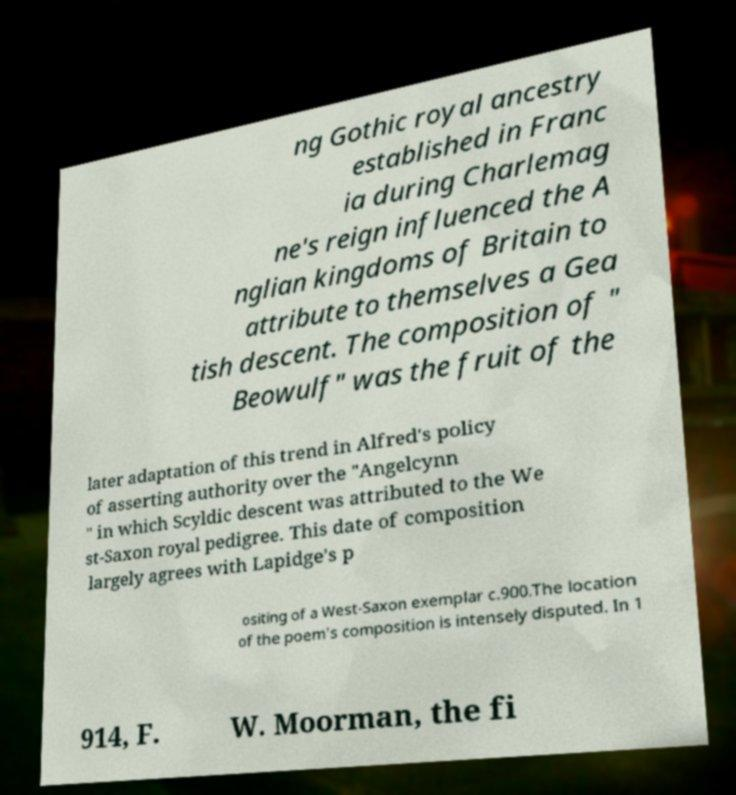Could you assist in decoding the text presented in this image and type it out clearly? ng Gothic royal ancestry established in Franc ia during Charlemag ne's reign influenced the A nglian kingdoms of Britain to attribute to themselves a Gea tish descent. The composition of " Beowulf" was the fruit of the later adaptation of this trend in Alfred's policy of asserting authority over the "Angelcynn " in which Scyldic descent was attributed to the We st-Saxon royal pedigree. This date of composition largely agrees with Lapidge's p ositing of a West-Saxon exemplar c.900.The location of the poem's composition is intensely disputed. In 1 914, F. W. Moorman, the fi 